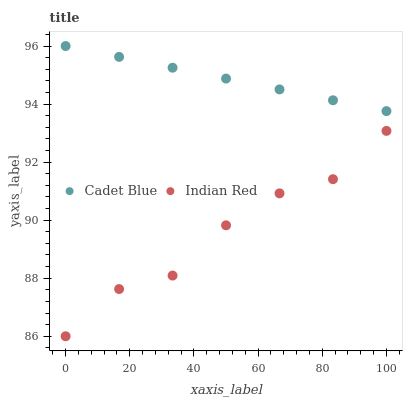Does Indian Red have the minimum area under the curve?
Answer yes or no. Yes. Does Cadet Blue have the maximum area under the curve?
Answer yes or no. Yes. Does Indian Red have the maximum area under the curve?
Answer yes or no. No. Is Cadet Blue the smoothest?
Answer yes or no. Yes. Is Indian Red the roughest?
Answer yes or no. Yes. Is Indian Red the smoothest?
Answer yes or no. No. Does Indian Red have the lowest value?
Answer yes or no. Yes. Does Cadet Blue have the highest value?
Answer yes or no. Yes. Does Indian Red have the highest value?
Answer yes or no. No. Is Indian Red less than Cadet Blue?
Answer yes or no. Yes. Is Cadet Blue greater than Indian Red?
Answer yes or no. Yes. Does Indian Red intersect Cadet Blue?
Answer yes or no. No. 